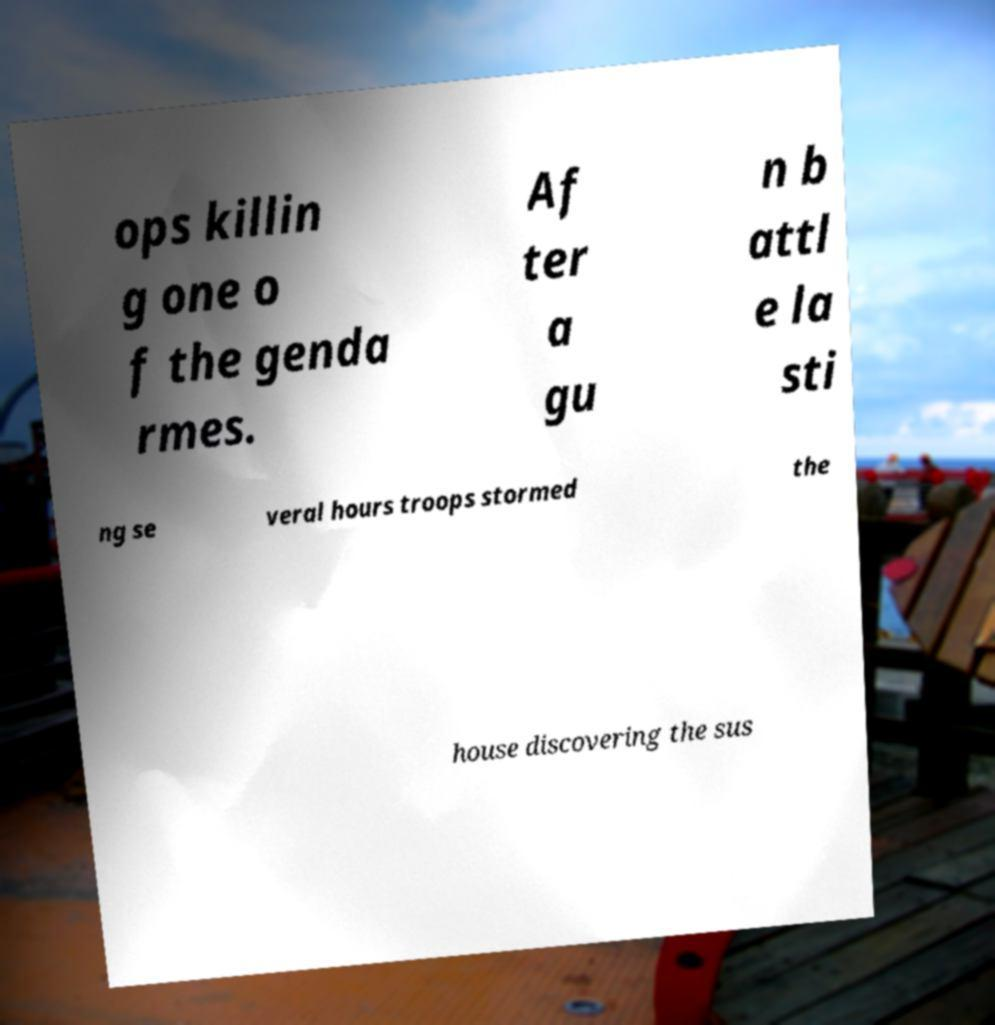Could you extract and type out the text from this image? ops killin g one o f the genda rmes. Af ter a gu n b attl e la sti ng se veral hours troops stormed the house discovering the sus 